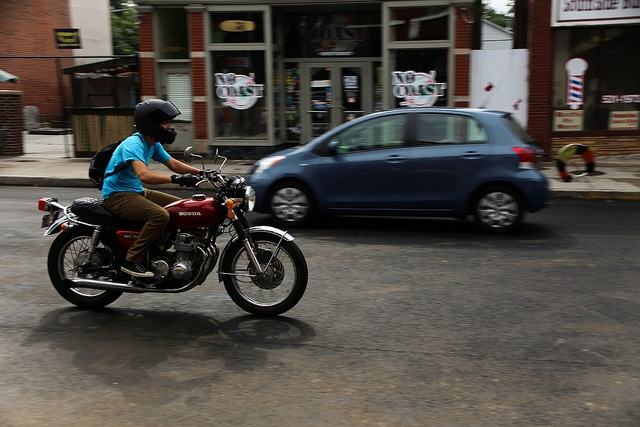Describe the objects in this image and their specific colors. I can see car in black, purple, gray, and blue tones, motorcycle in black, gray, darkgray, and maroon tones, people in black, maroon, gray, and lightblue tones, and backpack in black, lightblue, and navy tones in this image. 